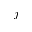Convert formula to latex. <formula><loc_0><loc_0><loc_500><loc_500>j</formula> 